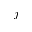Convert formula to latex. <formula><loc_0><loc_0><loc_500><loc_500>j</formula> 